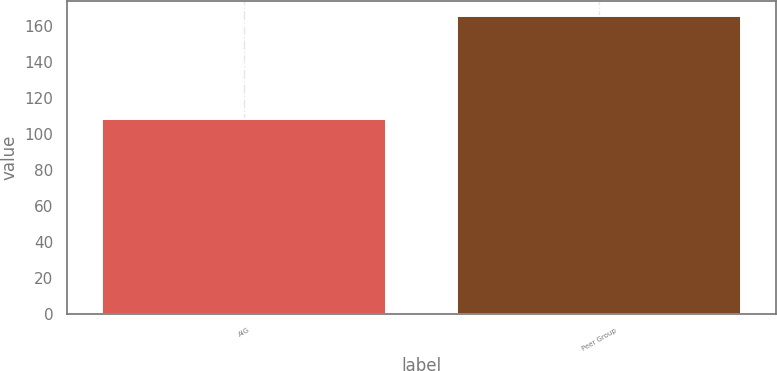Convert chart to OTSL. <chart><loc_0><loc_0><loc_500><loc_500><bar_chart><fcel>AIG<fcel>Peer Group<nl><fcel>108.38<fcel>165.52<nl></chart> 